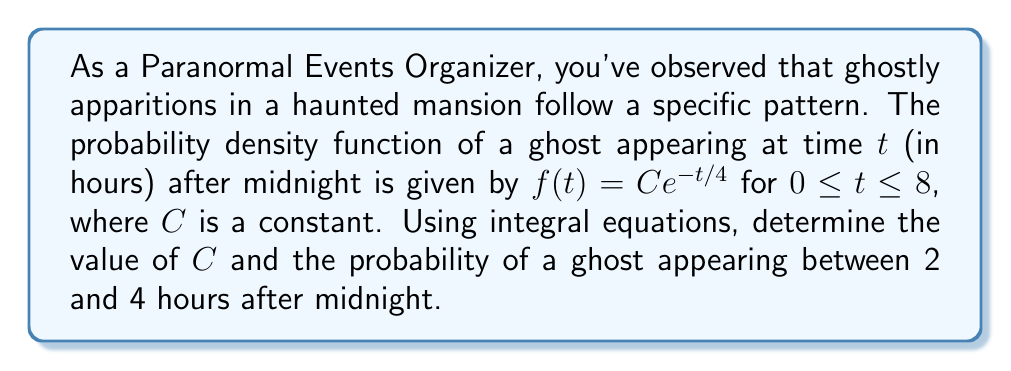Show me your answer to this math problem. 1. To find $C$, we use the fact that the total probability over the entire range must equal 1:

   $$\int_0^8 f(t)dt = 1$$

2. Substituting the given function:

   $$\int_0^8 Ce^{-t/4}dt = 1$$

3. Solve the integral:

   $$C \left[-4e^{-t/4}\right]_0^8 = 1$$
   $$C \left[-4e^{-8/4} + 4e^{-0/4}\right] = 1$$
   $$C \left[-4e^{-2} + 4\right] = 1$$
   $$C \left[4 - 4e^{-2}\right] = 1$$

4. Solve for $C$:

   $$C = \frac{1}{4 - 4e^{-2}} \approx 0.2869$$

5. To find the probability of a ghost appearing between 2 and 4 hours after midnight, we integrate the probability density function over this interval:

   $$P(2 \leq t \leq 4) = \int_2^4 Ce^{-t/4}dt$$

6. Substitute the value of $C$ and solve:

   $$P(2 \leq t \leq 4) = 0.2869 \int_2^4 e^{-t/4}dt$$
   $$= 0.2869 \left[-4e^{-t/4}\right]_2^4$$
   $$= 0.2869 \left[-4e^{-4/4} + 4e^{-2/4}\right]$$
   $$= 0.2869 \left[-4e^{-1} + 4e^{-1/2}\right]$$
   $$\approx 0.2067$$
Answer: $C \approx 0.2869$, $P(2 \leq t \leq 4) \approx 0.2067$ 